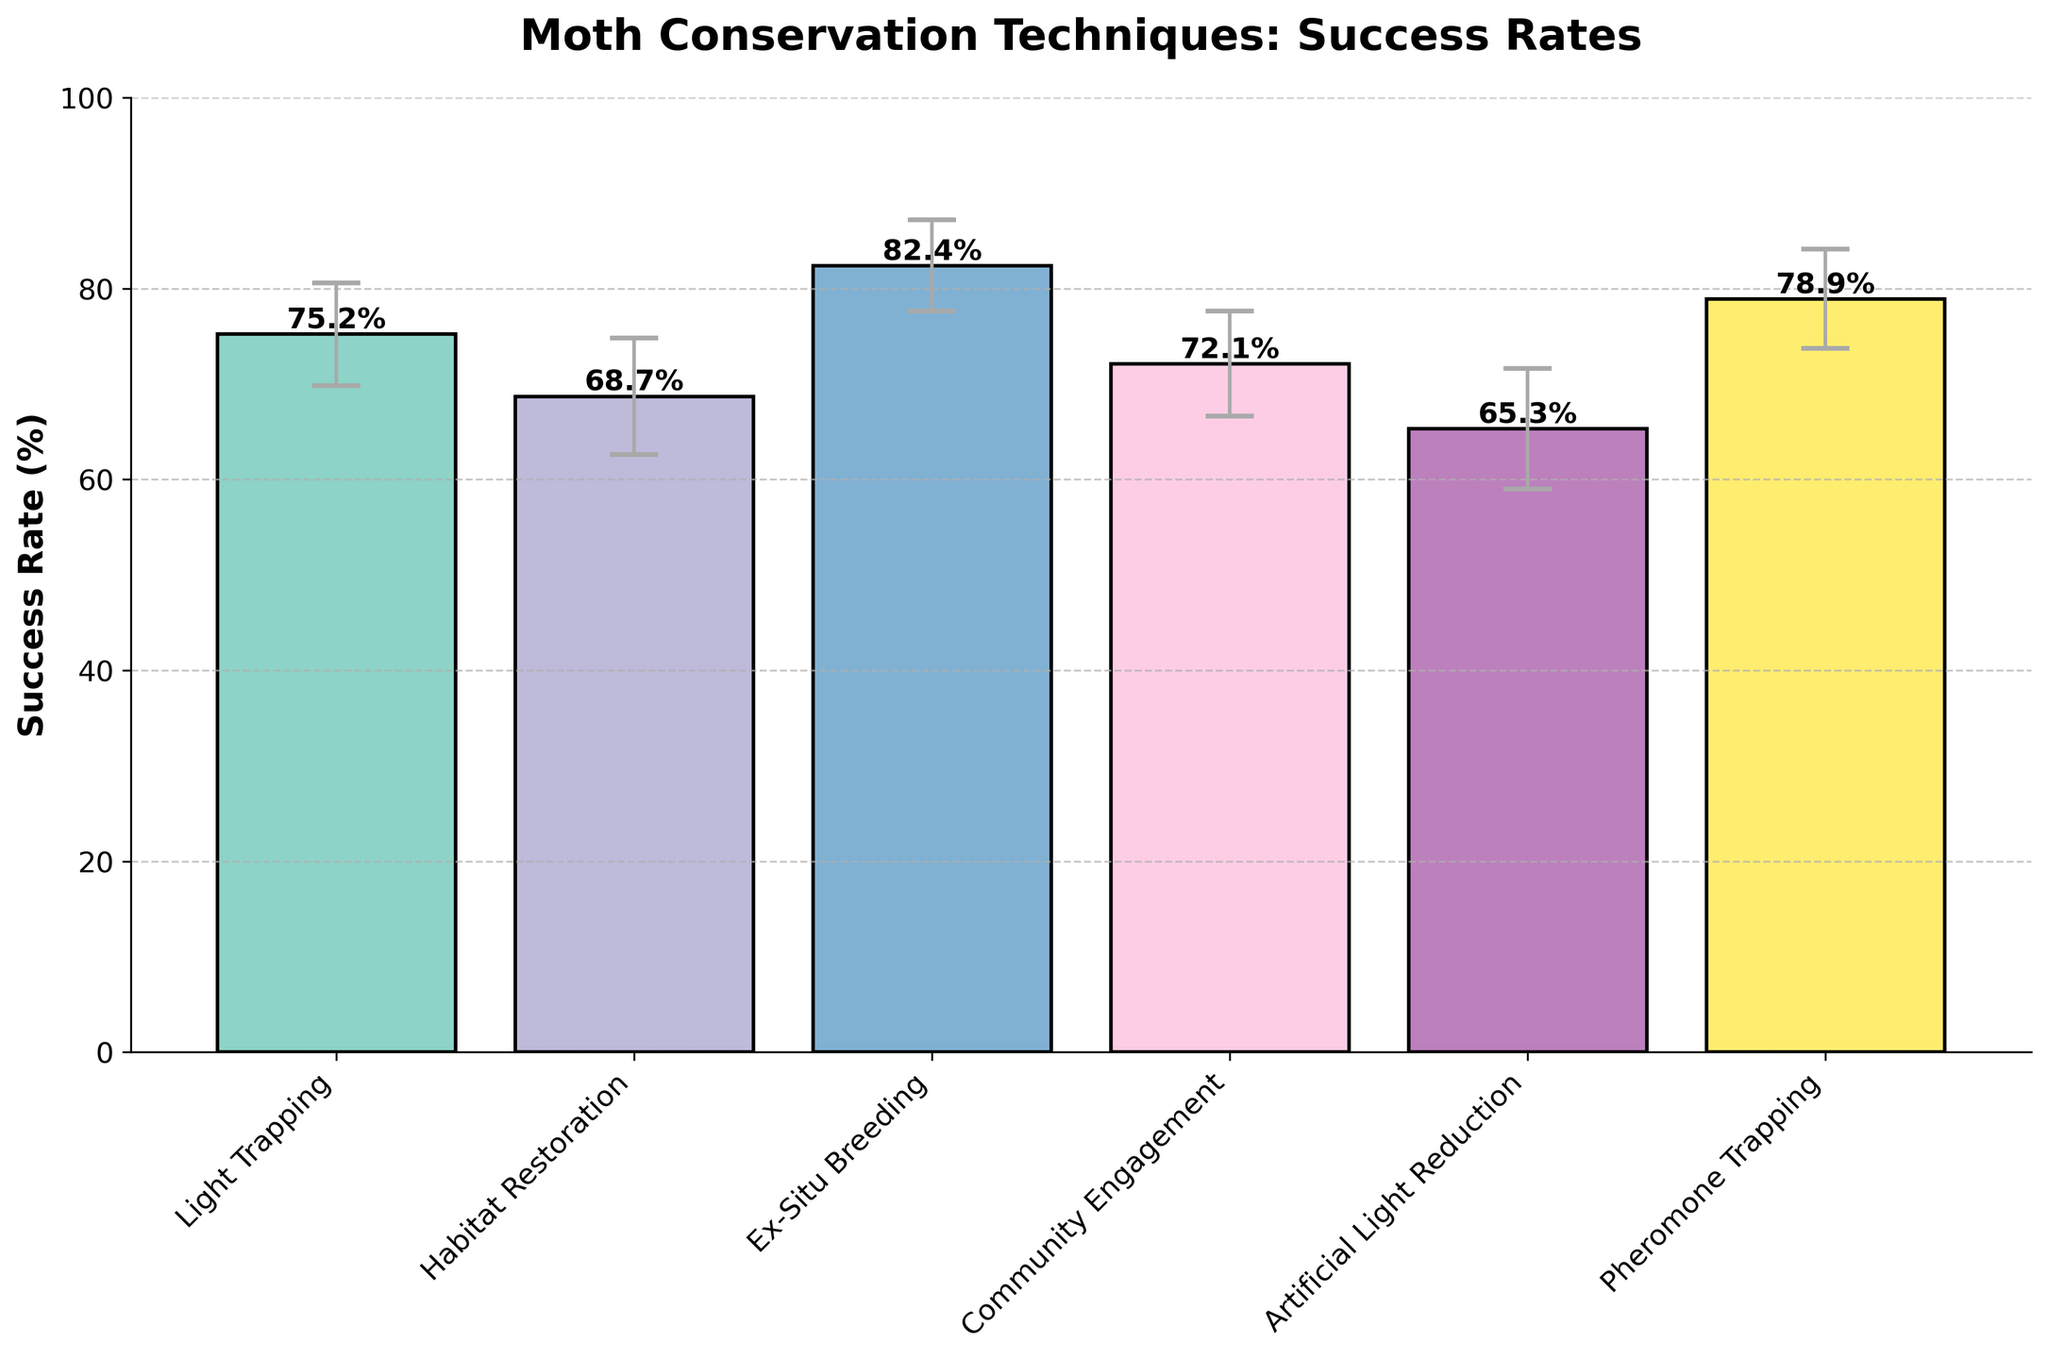What is the title of the plot? The title of the plot is located at the top of the figure. It is often bold and larger in font size compared to other text.
Answer: Moth Conservation Techniques: Success Rates What is the success rate for Community Engagement? Find the bar labeled "Community Engagement" on the x-axis and refer to its height in relation to the y-axis labels.
Answer: 72.1% Which technique has the highest success rate? Look at the heights of all the bars and identify the one that reaches the highest point.
Answer: Ex-Situ Breeding What are the standard deviations for Light Trapping and Pheromone Trapping? Refer to the error bars on top of "Light Trapping" and "Pheromone Trapping" bars, and identify the corresponding y-axis values.
Answer: 5.4%, 5.2% Which technique has the lowest success rate and what is that rate? Identify the bar with the shortest height.
Answer: Artificial Light Reduction, 65.3% What is the average success rate of all techniques? Add all the success rates together and divide by the number of techniques: (75.2 + 68.7 + 82.4 + 72.1 + 65.3 + 78.9) / 6.
Answer: 73.8% How much higher is the success rate for Ex-Situ Breeding compared to Habitat Restoration? Subtract the success rate of Habitat Restoration from that of Ex-Situ Breeding.
Answer: 13.7% Which technique has a greater success rate, Community Engagement or Artificial Light Reduction, and by how much? Compare the heights of the "Community Engagement" and "Artificial Light Reduction" bars and subtract the shorter from the taller.
Answer: Community Engagement, 6.8% Are there any techniques with overlapping error bars, indicating similar success rates due to variability? Compare the full range (mean ± standard deviation) for each technique to see if any overlap.
Answer: Yes, Light Trapping and Community Engagement could overlap given their SD ranges Which technique has the smallest standard deviation? Compare the lengths of the error bars above each bar; the shorter the error bar, the smaller the standard deviation.
Answer: Ex-Situ Breeding 